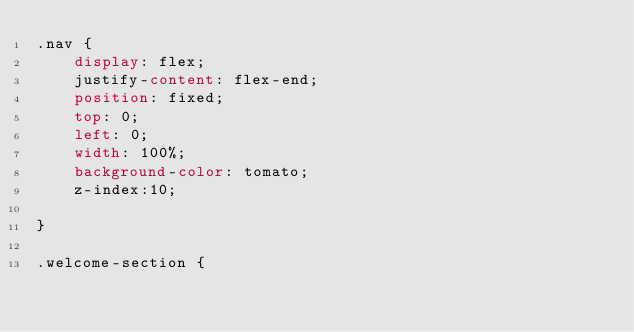<code> <loc_0><loc_0><loc_500><loc_500><_CSS_>.nav {
    display: flex;
    justify-content: flex-end;
    position: fixed;
    top: 0;
    left: 0;
    width: 100%;
    background-color: tomato;
    z-index:10;

}

.welcome-section {</code> 